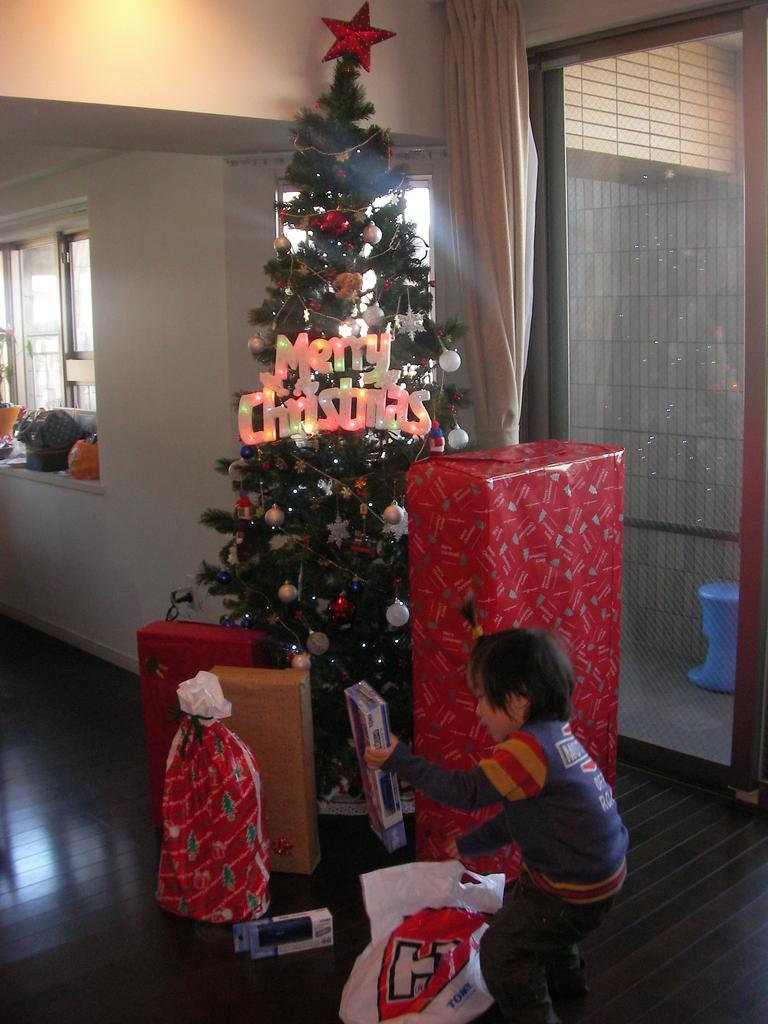Provide a one-sentence caption for the provided image. A boy in front of a Christmas tree with Merry Christmas illuminated. 